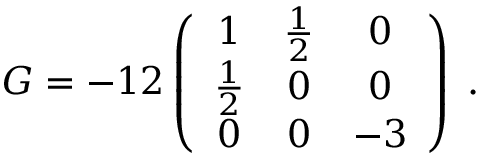<formula> <loc_0><loc_0><loc_500><loc_500>G = - 1 2 \left ( \begin{array} { c c c } { 1 } & { { \frac { 1 } { 2 } } } & { 0 } \\ { { \frac { 1 } { 2 } } } & { 0 } & { 0 } \\ { 0 } & { 0 } & { - 3 } \end{array} \right ) \, .</formula> 